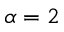<formula> <loc_0><loc_0><loc_500><loc_500>\alpha = 2</formula> 